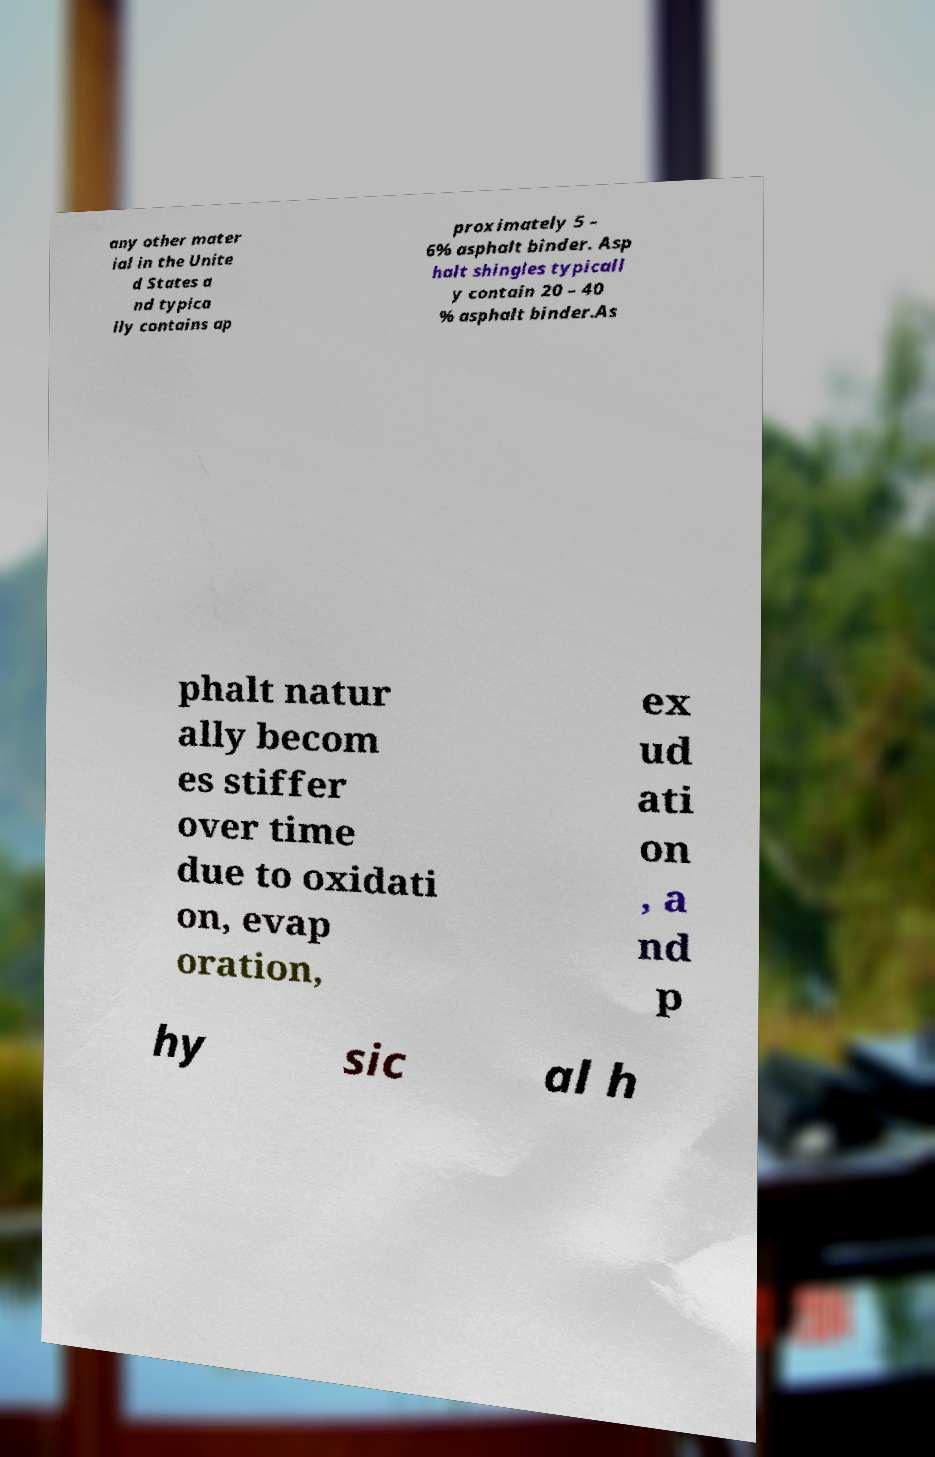Please read and relay the text visible in this image. What does it say? any other mater ial in the Unite d States a nd typica lly contains ap proximately 5 – 6% asphalt binder. Asp halt shingles typicall y contain 20 – 40 % asphalt binder.As phalt natur ally becom es stiffer over time due to oxidati on, evap oration, ex ud ati on , a nd p hy sic al h 